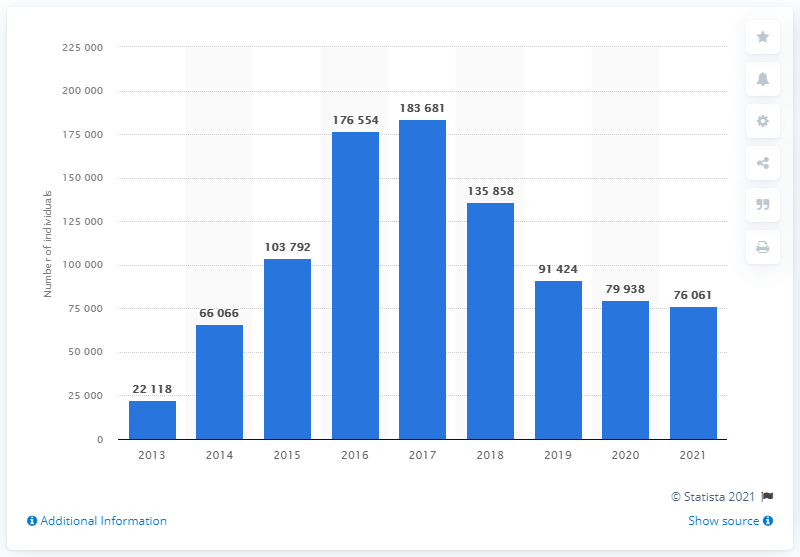Specify some key components in this picture. As of May 2021, it is known that approximately 76,061 migrants were housed in various types of reception centers in Italy. 